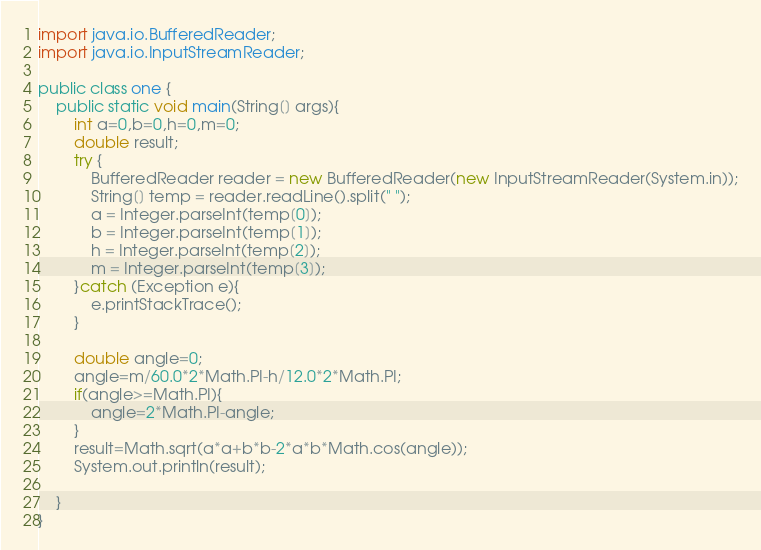<code> <loc_0><loc_0><loc_500><loc_500><_Java_>import java.io.BufferedReader;
import java.io.InputStreamReader;

public class one {
    public static void main(String[] args){
        int a=0,b=0,h=0,m=0;
        double result;
        try {
            BufferedReader reader = new BufferedReader(new InputStreamReader(System.in));
            String[] temp = reader.readLine().split(" ");
            a = Integer.parseInt(temp[0]);
            b = Integer.parseInt(temp[1]);
            h = Integer.parseInt(temp[2]);
            m = Integer.parseInt(temp[3]);
        }catch (Exception e){
            e.printStackTrace();
        }

        double angle=0;
        angle=m/60.0*2*Math.PI-h/12.0*2*Math.PI;
        if(angle>=Math.PI){
            angle=2*Math.PI-angle;
        }
        result=Math.sqrt(a*a+b*b-2*a*b*Math.cos(angle));
        System.out.println(result);

    }
}
</code> 